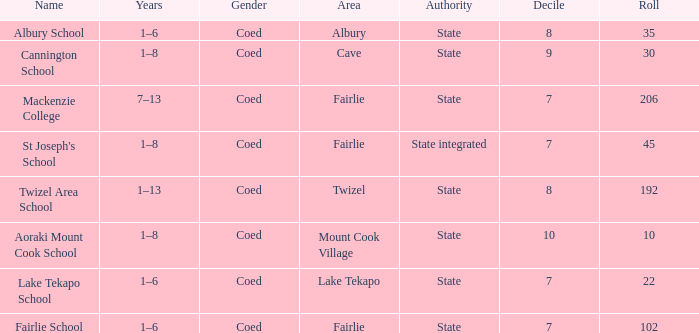What is the total Decile that has a state authority, fairlie area and roll smarter than 206? 1.0. Would you be able to parse every entry in this table? {'header': ['Name', 'Years', 'Gender', 'Area', 'Authority', 'Decile', 'Roll'], 'rows': [['Albury School', '1–6', 'Coed', 'Albury', 'State', '8', '35'], ['Cannington School', '1–8', 'Coed', 'Cave', 'State', '9', '30'], ['Mackenzie College', '7–13', 'Coed', 'Fairlie', 'State', '7', '206'], ["St Joseph's School", '1–8', 'Coed', 'Fairlie', 'State integrated', '7', '45'], ['Twizel Area School', '1–13', 'Coed', 'Twizel', 'State', '8', '192'], ['Aoraki Mount Cook School', '1–8', 'Coed', 'Mount Cook Village', 'State', '10', '10'], ['Lake Tekapo School', '1–6', 'Coed', 'Lake Tekapo', 'State', '7', '22'], ['Fairlie School', '1–6', 'Coed', 'Fairlie', 'State', '7', '102']]} 